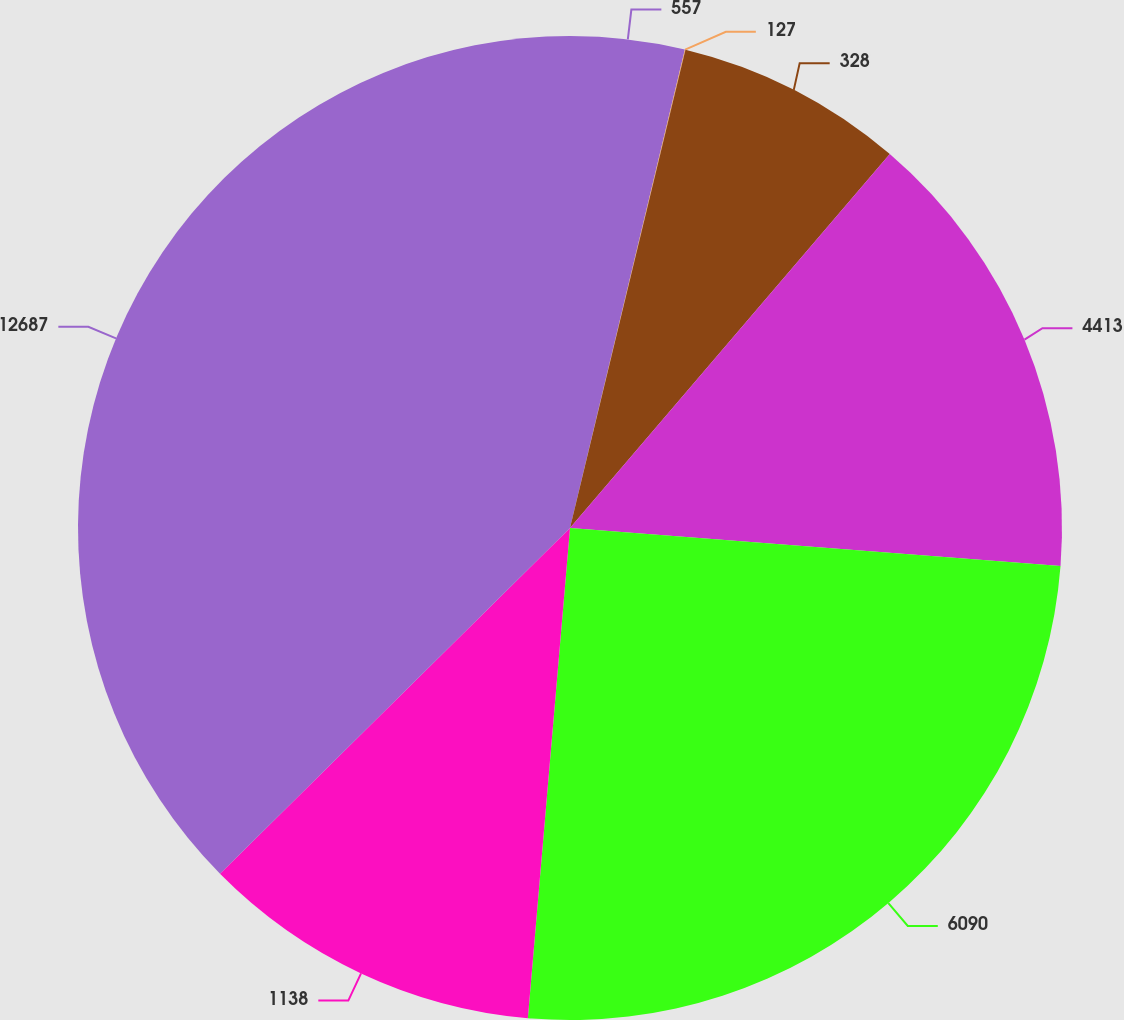Convert chart to OTSL. <chart><loc_0><loc_0><loc_500><loc_500><pie_chart><fcel>557<fcel>127<fcel>328<fcel>4413<fcel>6090<fcel>1138<fcel>12687<nl><fcel>3.75%<fcel>0.02%<fcel>7.49%<fcel>14.97%<fcel>25.13%<fcel>11.23%<fcel>37.4%<nl></chart> 